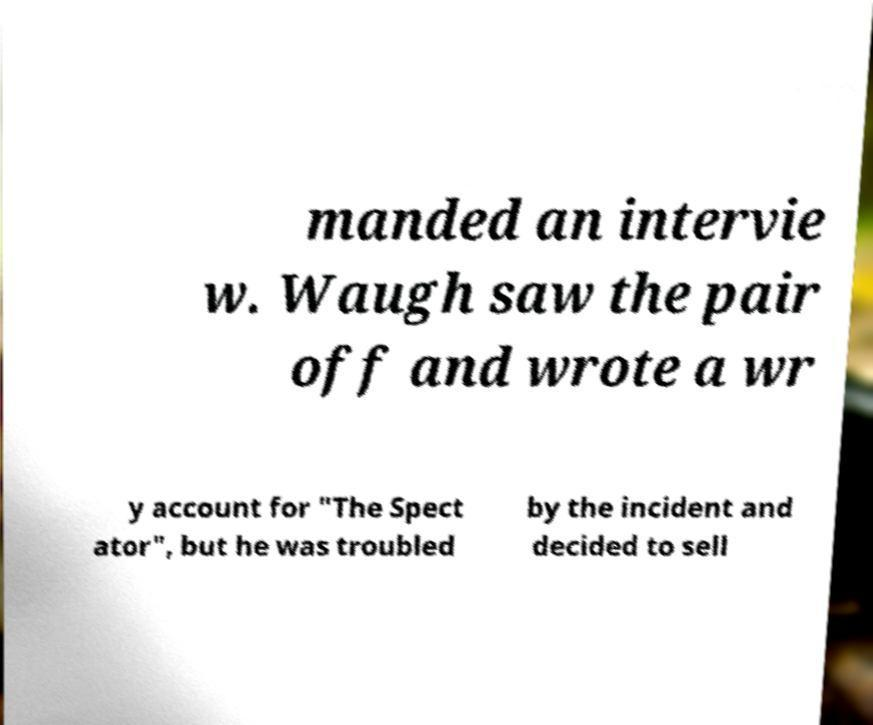Can you read and provide the text displayed in the image?This photo seems to have some interesting text. Can you extract and type it out for me? manded an intervie w. Waugh saw the pair off and wrote a wr y account for "The Spect ator", but he was troubled by the incident and decided to sell 